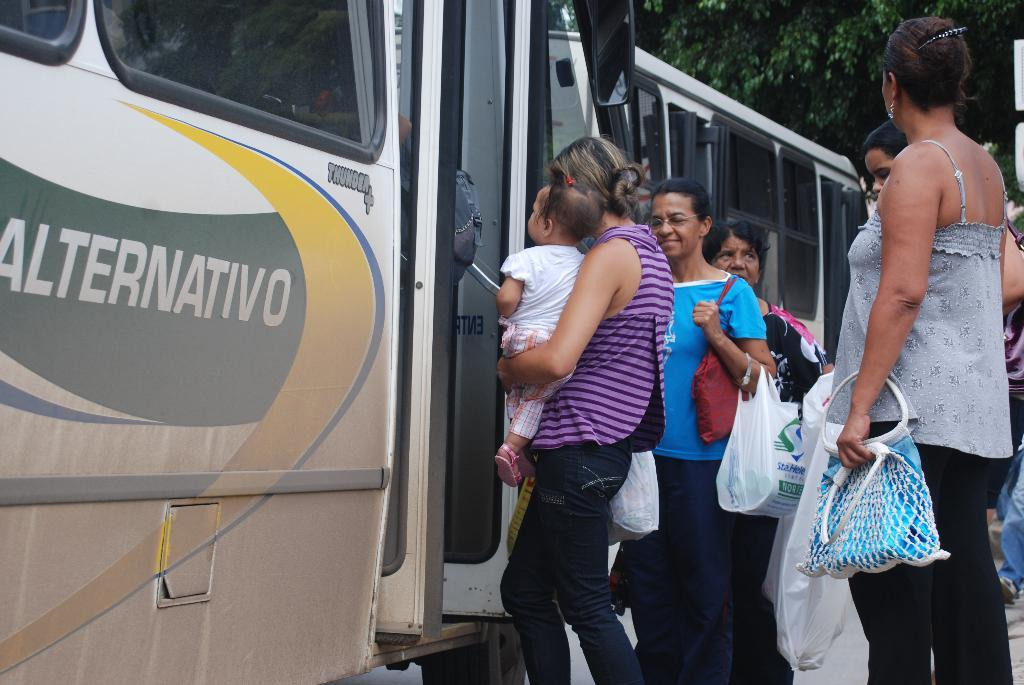What can be seen in the image besides people? There is a bus on the left side of the image, and there is a bus and a tree in the background of the image. How many buses are visible in the image? There are two buses visible in the image, one on the left side and another in the background. What is the location of the tree in the image? The tree is in the background of the image. What type of skirt is the stage wearing in the image? There is no stage or skirt present in the image. 